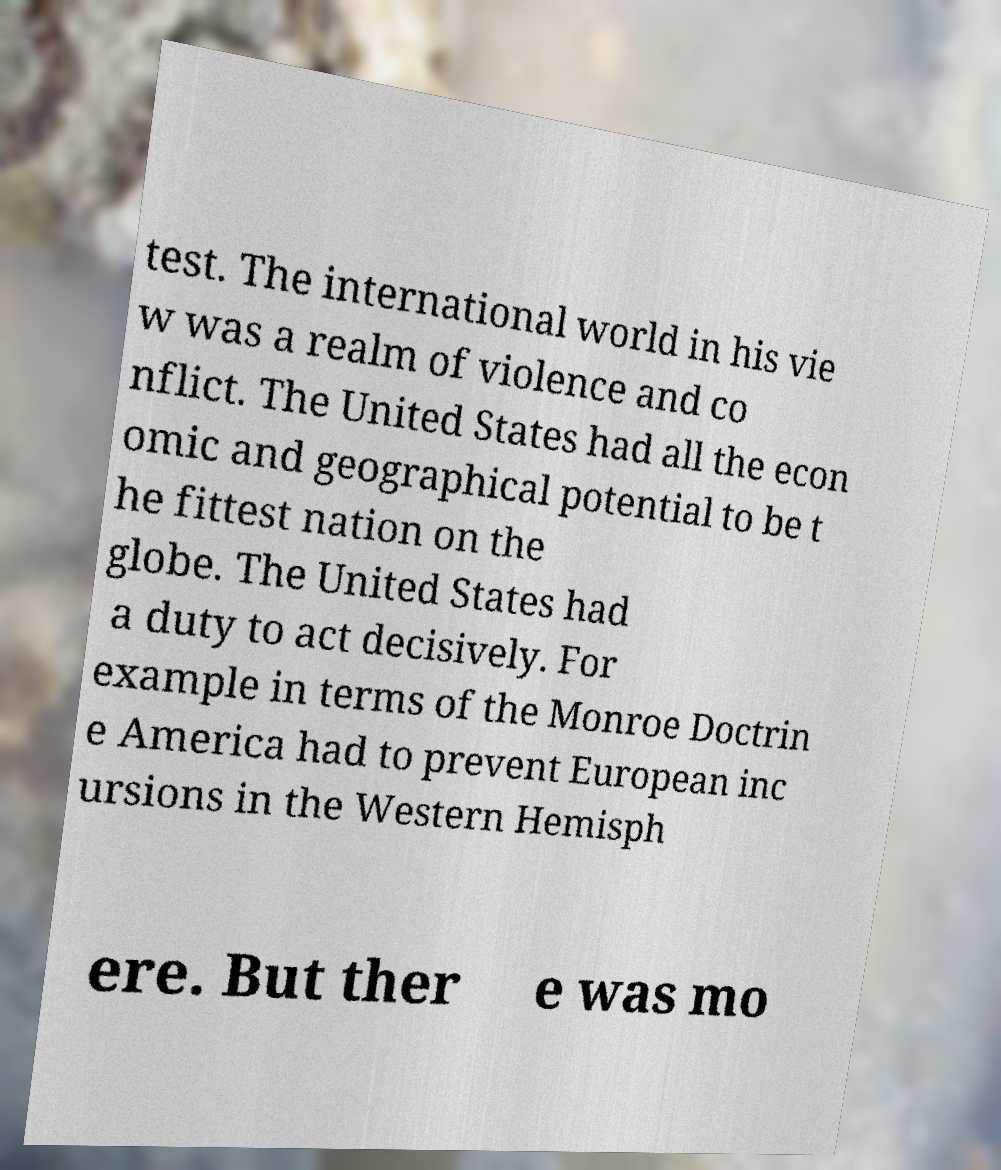For documentation purposes, I need the text within this image transcribed. Could you provide that? test. The international world in his vie w was a realm of violence and co nflict. The United States had all the econ omic and geographical potential to be t he fittest nation on the globe. The United States had a duty to act decisively. For example in terms of the Monroe Doctrin e America had to prevent European inc ursions in the Western Hemisph ere. But ther e was mo 